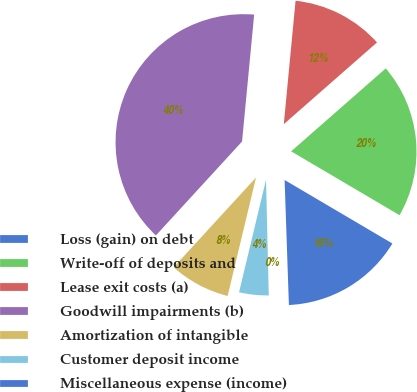Convert chart. <chart><loc_0><loc_0><loc_500><loc_500><pie_chart><fcel>Loss (gain) on debt<fcel>Write-off of deposits and<fcel>Lease exit costs (a)<fcel>Goodwill impairments (b)<fcel>Amortization of intangible<fcel>Customer deposit income<fcel>Miscellaneous expense (income)<nl><fcel>15.98%<fcel>19.93%<fcel>12.03%<fcel>39.7%<fcel>8.07%<fcel>4.12%<fcel>0.17%<nl></chart> 